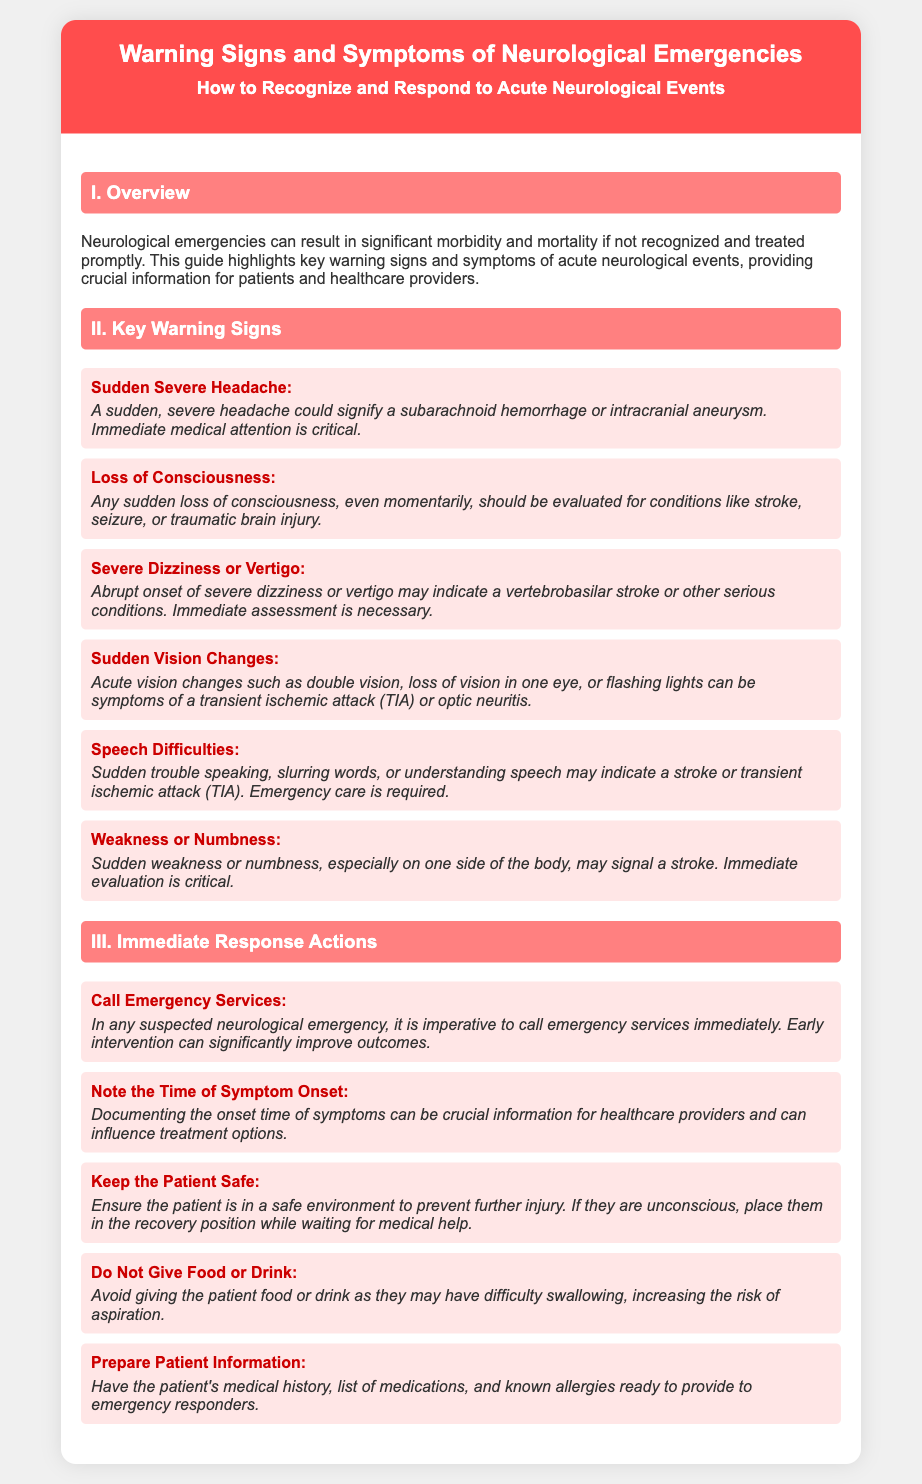What is the title of the document? The title is prominently displayed at the top of the document, highlighting its focus on neurological emergencies.
Answer: Warning Signs and Symptoms of Neurological Emergencies How many sections are in the document? The document is divided into three main sections: Overview, Key Warning Signs, and Immediate Response Actions.
Answer: Three What should you do if you suspect a neurological emergency? The immediate response actions advise to call emergency services in such cases.
Answer: Call Emergency Services Which sign indicates a subarachnoid hemorrhage? The document specifies that a sudden severe headache could indicate this condition.
Answer: Sudden Severe Headache What should you document in case of neurological symptoms? The guidance mentions that noting the time of symptom onset is crucial for healthcare providers.
Answer: Time of Symptom Onset What is the color of the header section? The header section's background color is specifically highlighted in the styles used for the document.
Answer: Red What is a common symptom of a stroke? The document lists weakness or numbness, especially on one side of the body, as a potential stroke indicator.
Answer: Weakness or Numbness What action should be avoided with the patient? One of the immediate response actions explicitly states not to give food or drink to the patient.
Answer: Do Not Give Food or Drink 